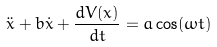<formula> <loc_0><loc_0><loc_500><loc_500>\ddot { x } + b \dot { x } + \frac { d V ( x ) } { d t } = a \cos ( \omega t )</formula> 